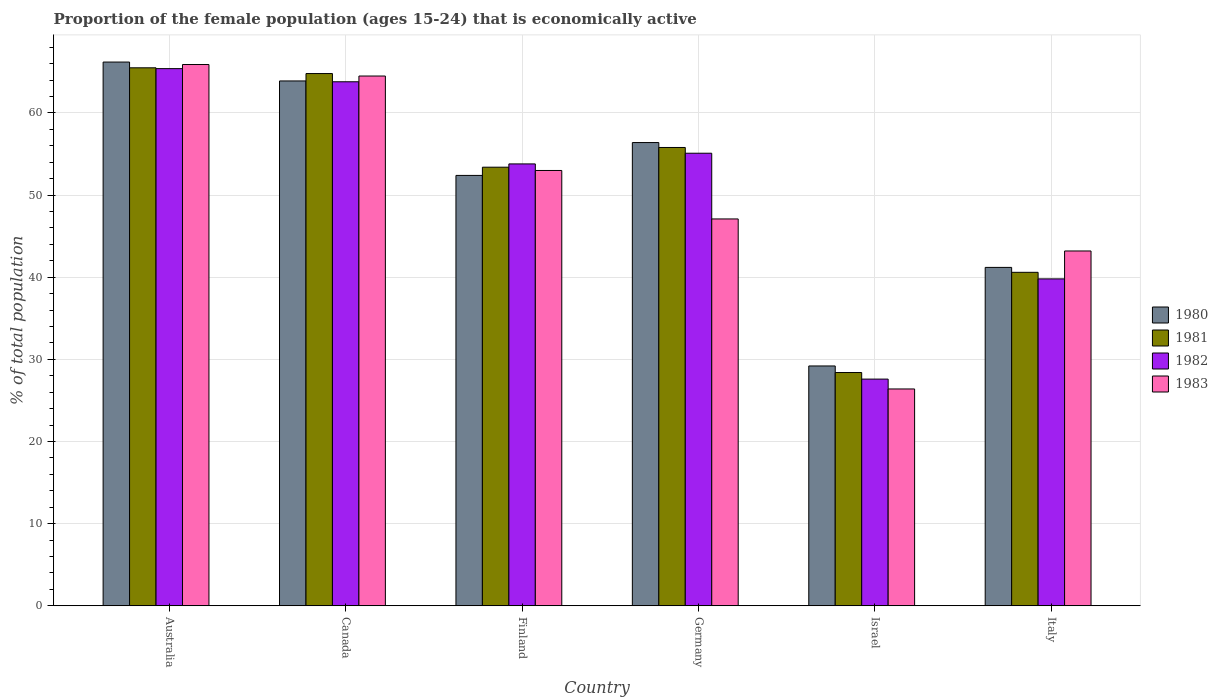How many groups of bars are there?
Keep it short and to the point. 6. Are the number of bars per tick equal to the number of legend labels?
Keep it short and to the point. Yes. How many bars are there on the 2nd tick from the left?
Provide a short and direct response. 4. In how many cases, is the number of bars for a given country not equal to the number of legend labels?
Your answer should be compact. 0. What is the proportion of the female population that is economically active in 1982 in Germany?
Make the answer very short. 55.1. Across all countries, what is the maximum proportion of the female population that is economically active in 1981?
Your response must be concise. 65.5. Across all countries, what is the minimum proportion of the female population that is economically active in 1981?
Make the answer very short. 28.4. In which country was the proportion of the female population that is economically active in 1983 maximum?
Your answer should be compact. Australia. In which country was the proportion of the female population that is economically active in 1980 minimum?
Give a very brief answer. Israel. What is the total proportion of the female population that is economically active in 1983 in the graph?
Give a very brief answer. 300.1. What is the difference between the proportion of the female population that is economically active in 1982 in Germany and that in Israel?
Offer a very short reply. 27.5. What is the difference between the proportion of the female population that is economically active in 1982 in Israel and the proportion of the female population that is economically active in 1980 in Canada?
Make the answer very short. -36.3. What is the average proportion of the female population that is economically active in 1983 per country?
Keep it short and to the point. 50.02. What is the difference between the proportion of the female population that is economically active of/in 1981 and proportion of the female population that is economically active of/in 1980 in Israel?
Provide a succinct answer. -0.8. What is the ratio of the proportion of the female population that is economically active in 1981 in Germany to that in Israel?
Provide a succinct answer. 1.96. Is the proportion of the female population that is economically active in 1981 in Finland less than that in Israel?
Your answer should be very brief. No. Is the difference between the proportion of the female population that is economically active in 1981 in Canada and Finland greater than the difference between the proportion of the female population that is economically active in 1980 in Canada and Finland?
Provide a succinct answer. No. What is the difference between the highest and the second highest proportion of the female population that is economically active in 1980?
Make the answer very short. -9.8. What is the difference between the highest and the lowest proportion of the female population that is economically active in 1983?
Ensure brevity in your answer.  39.5. In how many countries, is the proportion of the female population that is economically active in 1982 greater than the average proportion of the female population that is economically active in 1982 taken over all countries?
Your answer should be compact. 4. Is the sum of the proportion of the female population that is economically active in 1981 in Canada and Israel greater than the maximum proportion of the female population that is economically active in 1980 across all countries?
Make the answer very short. Yes. Is it the case that in every country, the sum of the proportion of the female population that is economically active in 1982 and proportion of the female population that is economically active in 1983 is greater than the sum of proportion of the female population that is economically active in 1981 and proportion of the female population that is economically active in 1980?
Provide a short and direct response. No. Are all the bars in the graph horizontal?
Your answer should be very brief. No. How many countries are there in the graph?
Offer a terse response. 6. What is the difference between two consecutive major ticks on the Y-axis?
Make the answer very short. 10. Are the values on the major ticks of Y-axis written in scientific E-notation?
Your response must be concise. No. Does the graph contain grids?
Make the answer very short. Yes. How many legend labels are there?
Offer a terse response. 4. How are the legend labels stacked?
Your response must be concise. Vertical. What is the title of the graph?
Give a very brief answer. Proportion of the female population (ages 15-24) that is economically active. What is the label or title of the Y-axis?
Keep it short and to the point. % of total population. What is the % of total population in 1980 in Australia?
Provide a succinct answer. 66.2. What is the % of total population of 1981 in Australia?
Your answer should be very brief. 65.5. What is the % of total population of 1982 in Australia?
Your answer should be compact. 65.4. What is the % of total population of 1983 in Australia?
Offer a very short reply. 65.9. What is the % of total population of 1980 in Canada?
Provide a short and direct response. 63.9. What is the % of total population in 1981 in Canada?
Provide a succinct answer. 64.8. What is the % of total population in 1982 in Canada?
Your response must be concise. 63.8. What is the % of total population of 1983 in Canada?
Your answer should be compact. 64.5. What is the % of total population in 1980 in Finland?
Provide a succinct answer. 52.4. What is the % of total population in 1981 in Finland?
Make the answer very short. 53.4. What is the % of total population of 1982 in Finland?
Ensure brevity in your answer.  53.8. What is the % of total population in 1983 in Finland?
Ensure brevity in your answer.  53. What is the % of total population of 1980 in Germany?
Your response must be concise. 56.4. What is the % of total population in 1981 in Germany?
Ensure brevity in your answer.  55.8. What is the % of total population in 1982 in Germany?
Offer a very short reply. 55.1. What is the % of total population of 1983 in Germany?
Provide a succinct answer. 47.1. What is the % of total population of 1980 in Israel?
Your response must be concise. 29.2. What is the % of total population of 1981 in Israel?
Keep it short and to the point. 28.4. What is the % of total population of 1982 in Israel?
Your answer should be compact. 27.6. What is the % of total population of 1983 in Israel?
Give a very brief answer. 26.4. What is the % of total population in 1980 in Italy?
Your answer should be compact. 41.2. What is the % of total population of 1981 in Italy?
Give a very brief answer. 40.6. What is the % of total population in 1982 in Italy?
Your response must be concise. 39.8. What is the % of total population of 1983 in Italy?
Your response must be concise. 43.2. Across all countries, what is the maximum % of total population of 1980?
Give a very brief answer. 66.2. Across all countries, what is the maximum % of total population of 1981?
Your answer should be compact. 65.5. Across all countries, what is the maximum % of total population of 1982?
Provide a short and direct response. 65.4. Across all countries, what is the maximum % of total population in 1983?
Your answer should be compact. 65.9. Across all countries, what is the minimum % of total population in 1980?
Offer a terse response. 29.2. Across all countries, what is the minimum % of total population in 1981?
Offer a very short reply. 28.4. Across all countries, what is the minimum % of total population in 1982?
Make the answer very short. 27.6. Across all countries, what is the minimum % of total population in 1983?
Your answer should be very brief. 26.4. What is the total % of total population of 1980 in the graph?
Provide a succinct answer. 309.3. What is the total % of total population of 1981 in the graph?
Provide a short and direct response. 308.5. What is the total % of total population in 1982 in the graph?
Provide a short and direct response. 305.5. What is the total % of total population of 1983 in the graph?
Offer a very short reply. 300.1. What is the difference between the % of total population in 1982 in Australia and that in Canada?
Make the answer very short. 1.6. What is the difference between the % of total population in 1983 in Australia and that in Canada?
Offer a very short reply. 1.4. What is the difference between the % of total population of 1980 in Australia and that in Finland?
Keep it short and to the point. 13.8. What is the difference between the % of total population of 1981 in Australia and that in Finland?
Your answer should be very brief. 12.1. What is the difference between the % of total population of 1982 in Australia and that in Finland?
Provide a succinct answer. 11.6. What is the difference between the % of total population in 1980 in Australia and that in Germany?
Give a very brief answer. 9.8. What is the difference between the % of total population in 1982 in Australia and that in Germany?
Give a very brief answer. 10.3. What is the difference between the % of total population of 1980 in Australia and that in Israel?
Provide a short and direct response. 37. What is the difference between the % of total population in 1981 in Australia and that in Israel?
Offer a very short reply. 37.1. What is the difference between the % of total population of 1982 in Australia and that in Israel?
Offer a very short reply. 37.8. What is the difference between the % of total population of 1983 in Australia and that in Israel?
Your answer should be compact. 39.5. What is the difference between the % of total population of 1981 in Australia and that in Italy?
Your answer should be very brief. 24.9. What is the difference between the % of total population in 1982 in Australia and that in Italy?
Provide a short and direct response. 25.6. What is the difference between the % of total population in 1983 in Australia and that in Italy?
Make the answer very short. 22.7. What is the difference between the % of total population in 1983 in Canada and that in Finland?
Keep it short and to the point. 11.5. What is the difference between the % of total population in 1980 in Canada and that in Israel?
Give a very brief answer. 34.7. What is the difference between the % of total population of 1981 in Canada and that in Israel?
Your answer should be compact. 36.4. What is the difference between the % of total population of 1982 in Canada and that in Israel?
Provide a short and direct response. 36.2. What is the difference between the % of total population of 1983 in Canada and that in Israel?
Provide a short and direct response. 38.1. What is the difference between the % of total population of 1980 in Canada and that in Italy?
Your answer should be very brief. 22.7. What is the difference between the % of total population in 1981 in Canada and that in Italy?
Offer a terse response. 24.2. What is the difference between the % of total population in 1983 in Canada and that in Italy?
Give a very brief answer. 21.3. What is the difference between the % of total population of 1980 in Finland and that in Germany?
Your response must be concise. -4. What is the difference between the % of total population in 1981 in Finland and that in Germany?
Ensure brevity in your answer.  -2.4. What is the difference between the % of total population of 1982 in Finland and that in Germany?
Give a very brief answer. -1.3. What is the difference between the % of total population of 1983 in Finland and that in Germany?
Give a very brief answer. 5.9. What is the difference between the % of total population of 1980 in Finland and that in Israel?
Your response must be concise. 23.2. What is the difference between the % of total population in 1981 in Finland and that in Israel?
Your response must be concise. 25. What is the difference between the % of total population in 1982 in Finland and that in Israel?
Offer a terse response. 26.2. What is the difference between the % of total population of 1983 in Finland and that in Israel?
Keep it short and to the point. 26.6. What is the difference between the % of total population of 1983 in Finland and that in Italy?
Your answer should be very brief. 9.8. What is the difference between the % of total population in 1980 in Germany and that in Israel?
Your response must be concise. 27.2. What is the difference between the % of total population of 1981 in Germany and that in Israel?
Your response must be concise. 27.4. What is the difference between the % of total population of 1982 in Germany and that in Israel?
Give a very brief answer. 27.5. What is the difference between the % of total population in 1983 in Germany and that in Israel?
Your response must be concise. 20.7. What is the difference between the % of total population of 1980 in Germany and that in Italy?
Offer a very short reply. 15.2. What is the difference between the % of total population in 1983 in Germany and that in Italy?
Make the answer very short. 3.9. What is the difference between the % of total population of 1982 in Israel and that in Italy?
Offer a terse response. -12.2. What is the difference between the % of total population of 1983 in Israel and that in Italy?
Give a very brief answer. -16.8. What is the difference between the % of total population of 1980 in Australia and the % of total population of 1981 in Canada?
Provide a succinct answer. 1.4. What is the difference between the % of total population in 1981 in Australia and the % of total population in 1983 in Canada?
Offer a very short reply. 1. What is the difference between the % of total population of 1981 in Australia and the % of total population of 1982 in Finland?
Make the answer very short. 11.7. What is the difference between the % of total population in 1980 in Australia and the % of total population in 1981 in Germany?
Your answer should be compact. 10.4. What is the difference between the % of total population of 1981 in Australia and the % of total population of 1983 in Germany?
Give a very brief answer. 18.4. What is the difference between the % of total population of 1980 in Australia and the % of total population of 1981 in Israel?
Keep it short and to the point. 37.8. What is the difference between the % of total population in 1980 in Australia and the % of total population in 1982 in Israel?
Your answer should be compact. 38.6. What is the difference between the % of total population in 1980 in Australia and the % of total population in 1983 in Israel?
Provide a succinct answer. 39.8. What is the difference between the % of total population in 1981 in Australia and the % of total population in 1982 in Israel?
Your response must be concise. 37.9. What is the difference between the % of total population in 1981 in Australia and the % of total population in 1983 in Israel?
Make the answer very short. 39.1. What is the difference between the % of total population of 1980 in Australia and the % of total population of 1981 in Italy?
Your answer should be compact. 25.6. What is the difference between the % of total population in 1980 in Australia and the % of total population in 1982 in Italy?
Provide a succinct answer. 26.4. What is the difference between the % of total population of 1981 in Australia and the % of total population of 1982 in Italy?
Your answer should be very brief. 25.7. What is the difference between the % of total population of 1981 in Australia and the % of total population of 1983 in Italy?
Offer a very short reply. 22.3. What is the difference between the % of total population of 1980 in Canada and the % of total population of 1981 in Finland?
Your response must be concise. 10.5. What is the difference between the % of total population of 1980 in Canada and the % of total population of 1983 in Finland?
Keep it short and to the point. 10.9. What is the difference between the % of total population in 1981 in Canada and the % of total population in 1983 in Finland?
Provide a succinct answer. 11.8. What is the difference between the % of total population in 1982 in Canada and the % of total population in 1983 in Finland?
Your response must be concise. 10.8. What is the difference between the % of total population in 1980 in Canada and the % of total population in 1981 in Germany?
Your answer should be very brief. 8.1. What is the difference between the % of total population in 1980 in Canada and the % of total population in 1983 in Germany?
Offer a very short reply. 16.8. What is the difference between the % of total population of 1981 in Canada and the % of total population of 1982 in Germany?
Provide a short and direct response. 9.7. What is the difference between the % of total population of 1980 in Canada and the % of total population of 1981 in Israel?
Keep it short and to the point. 35.5. What is the difference between the % of total population of 1980 in Canada and the % of total population of 1982 in Israel?
Provide a short and direct response. 36.3. What is the difference between the % of total population in 1980 in Canada and the % of total population in 1983 in Israel?
Ensure brevity in your answer.  37.5. What is the difference between the % of total population in 1981 in Canada and the % of total population in 1982 in Israel?
Ensure brevity in your answer.  37.2. What is the difference between the % of total population in 1981 in Canada and the % of total population in 1983 in Israel?
Your answer should be compact. 38.4. What is the difference between the % of total population of 1982 in Canada and the % of total population of 1983 in Israel?
Ensure brevity in your answer.  37.4. What is the difference between the % of total population in 1980 in Canada and the % of total population in 1981 in Italy?
Provide a succinct answer. 23.3. What is the difference between the % of total population in 1980 in Canada and the % of total population in 1982 in Italy?
Make the answer very short. 24.1. What is the difference between the % of total population in 1980 in Canada and the % of total population in 1983 in Italy?
Offer a terse response. 20.7. What is the difference between the % of total population of 1981 in Canada and the % of total population of 1983 in Italy?
Provide a succinct answer. 21.6. What is the difference between the % of total population in 1982 in Canada and the % of total population in 1983 in Italy?
Provide a succinct answer. 20.6. What is the difference between the % of total population in 1980 in Finland and the % of total population in 1981 in Germany?
Give a very brief answer. -3.4. What is the difference between the % of total population of 1980 in Finland and the % of total population of 1983 in Germany?
Your answer should be compact. 5.3. What is the difference between the % of total population of 1981 in Finland and the % of total population of 1982 in Germany?
Your answer should be compact. -1.7. What is the difference between the % of total population in 1981 in Finland and the % of total population in 1983 in Germany?
Your answer should be compact. 6.3. What is the difference between the % of total population of 1982 in Finland and the % of total population of 1983 in Germany?
Your response must be concise. 6.7. What is the difference between the % of total population in 1980 in Finland and the % of total population in 1981 in Israel?
Your answer should be compact. 24. What is the difference between the % of total population of 1980 in Finland and the % of total population of 1982 in Israel?
Your answer should be compact. 24.8. What is the difference between the % of total population of 1981 in Finland and the % of total population of 1982 in Israel?
Your response must be concise. 25.8. What is the difference between the % of total population of 1981 in Finland and the % of total population of 1983 in Israel?
Provide a succinct answer. 27. What is the difference between the % of total population in 1982 in Finland and the % of total population in 1983 in Israel?
Offer a very short reply. 27.4. What is the difference between the % of total population in 1980 in Finland and the % of total population in 1981 in Italy?
Your answer should be very brief. 11.8. What is the difference between the % of total population in 1980 in Finland and the % of total population in 1982 in Italy?
Keep it short and to the point. 12.6. What is the difference between the % of total population of 1980 in Finland and the % of total population of 1983 in Italy?
Your answer should be compact. 9.2. What is the difference between the % of total population in 1981 in Finland and the % of total population in 1983 in Italy?
Offer a very short reply. 10.2. What is the difference between the % of total population of 1980 in Germany and the % of total population of 1981 in Israel?
Your answer should be very brief. 28. What is the difference between the % of total population of 1980 in Germany and the % of total population of 1982 in Israel?
Give a very brief answer. 28.8. What is the difference between the % of total population of 1981 in Germany and the % of total population of 1982 in Israel?
Your response must be concise. 28.2. What is the difference between the % of total population in 1981 in Germany and the % of total population in 1983 in Israel?
Make the answer very short. 29.4. What is the difference between the % of total population of 1982 in Germany and the % of total population of 1983 in Israel?
Offer a terse response. 28.7. What is the difference between the % of total population of 1980 in Germany and the % of total population of 1982 in Italy?
Provide a succinct answer. 16.6. What is the difference between the % of total population in 1981 in Germany and the % of total population in 1982 in Italy?
Your answer should be very brief. 16. What is the difference between the % of total population of 1980 in Israel and the % of total population of 1981 in Italy?
Offer a terse response. -11.4. What is the difference between the % of total population of 1980 in Israel and the % of total population of 1982 in Italy?
Provide a short and direct response. -10.6. What is the difference between the % of total population of 1980 in Israel and the % of total population of 1983 in Italy?
Give a very brief answer. -14. What is the difference between the % of total population of 1981 in Israel and the % of total population of 1983 in Italy?
Give a very brief answer. -14.8. What is the difference between the % of total population of 1982 in Israel and the % of total population of 1983 in Italy?
Ensure brevity in your answer.  -15.6. What is the average % of total population in 1980 per country?
Offer a terse response. 51.55. What is the average % of total population in 1981 per country?
Keep it short and to the point. 51.42. What is the average % of total population of 1982 per country?
Offer a very short reply. 50.92. What is the average % of total population of 1983 per country?
Your response must be concise. 50.02. What is the difference between the % of total population of 1980 and % of total population of 1981 in Australia?
Provide a short and direct response. 0.7. What is the difference between the % of total population of 1980 and % of total population of 1982 in Australia?
Your response must be concise. 0.8. What is the difference between the % of total population of 1980 and % of total population of 1983 in Australia?
Your answer should be very brief. 0.3. What is the difference between the % of total population of 1981 and % of total population of 1982 in Australia?
Give a very brief answer. 0.1. What is the difference between the % of total population in 1981 and % of total population in 1983 in Australia?
Keep it short and to the point. -0.4. What is the difference between the % of total population in 1980 and % of total population in 1981 in Canada?
Make the answer very short. -0.9. What is the difference between the % of total population of 1980 and % of total population of 1982 in Canada?
Ensure brevity in your answer.  0.1. What is the difference between the % of total population of 1981 and % of total population of 1983 in Canada?
Your answer should be very brief. 0.3. What is the difference between the % of total population in 1980 and % of total population in 1981 in Finland?
Your answer should be compact. -1. What is the difference between the % of total population in 1980 and % of total population in 1982 in Finland?
Offer a very short reply. -1.4. What is the difference between the % of total population of 1980 and % of total population of 1983 in Finland?
Give a very brief answer. -0.6. What is the difference between the % of total population of 1981 and % of total population of 1983 in Finland?
Provide a succinct answer. 0.4. What is the difference between the % of total population in 1980 and % of total population in 1982 in Germany?
Keep it short and to the point. 1.3. What is the difference between the % of total population of 1981 and % of total population of 1983 in Germany?
Offer a very short reply. 8.7. What is the difference between the % of total population of 1982 and % of total population of 1983 in Germany?
Make the answer very short. 8. What is the difference between the % of total population in 1980 and % of total population in 1983 in Israel?
Offer a terse response. 2.8. What is the difference between the % of total population of 1981 and % of total population of 1982 in Israel?
Make the answer very short. 0.8. What is the difference between the % of total population of 1980 and % of total population of 1981 in Italy?
Offer a terse response. 0.6. What is the difference between the % of total population in 1980 and % of total population in 1982 in Italy?
Offer a very short reply. 1.4. What is the difference between the % of total population of 1981 and % of total population of 1982 in Italy?
Make the answer very short. 0.8. What is the difference between the % of total population of 1981 and % of total population of 1983 in Italy?
Provide a succinct answer. -2.6. What is the ratio of the % of total population in 1980 in Australia to that in Canada?
Your answer should be compact. 1.04. What is the ratio of the % of total population of 1981 in Australia to that in Canada?
Your response must be concise. 1.01. What is the ratio of the % of total population in 1982 in Australia to that in Canada?
Offer a terse response. 1.03. What is the ratio of the % of total population of 1983 in Australia to that in Canada?
Give a very brief answer. 1.02. What is the ratio of the % of total population of 1980 in Australia to that in Finland?
Offer a terse response. 1.26. What is the ratio of the % of total population in 1981 in Australia to that in Finland?
Your response must be concise. 1.23. What is the ratio of the % of total population in 1982 in Australia to that in Finland?
Keep it short and to the point. 1.22. What is the ratio of the % of total population in 1983 in Australia to that in Finland?
Give a very brief answer. 1.24. What is the ratio of the % of total population in 1980 in Australia to that in Germany?
Keep it short and to the point. 1.17. What is the ratio of the % of total population in 1981 in Australia to that in Germany?
Your answer should be compact. 1.17. What is the ratio of the % of total population of 1982 in Australia to that in Germany?
Offer a terse response. 1.19. What is the ratio of the % of total population of 1983 in Australia to that in Germany?
Offer a very short reply. 1.4. What is the ratio of the % of total population of 1980 in Australia to that in Israel?
Provide a short and direct response. 2.27. What is the ratio of the % of total population in 1981 in Australia to that in Israel?
Give a very brief answer. 2.31. What is the ratio of the % of total population of 1982 in Australia to that in Israel?
Your answer should be compact. 2.37. What is the ratio of the % of total population of 1983 in Australia to that in Israel?
Your answer should be very brief. 2.5. What is the ratio of the % of total population of 1980 in Australia to that in Italy?
Offer a very short reply. 1.61. What is the ratio of the % of total population of 1981 in Australia to that in Italy?
Keep it short and to the point. 1.61. What is the ratio of the % of total population of 1982 in Australia to that in Italy?
Give a very brief answer. 1.64. What is the ratio of the % of total population in 1983 in Australia to that in Italy?
Your answer should be compact. 1.53. What is the ratio of the % of total population in 1980 in Canada to that in Finland?
Keep it short and to the point. 1.22. What is the ratio of the % of total population of 1981 in Canada to that in Finland?
Provide a succinct answer. 1.21. What is the ratio of the % of total population in 1982 in Canada to that in Finland?
Make the answer very short. 1.19. What is the ratio of the % of total population of 1983 in Canada to that in Finland?
Keep it short and to the point. 1.22. What is the ratio of the % of total population in 1980 in Canada to that in Germany?
Your answer should be compact. 1.13. What is the ratio of the % of total population in 1981 in Canada to that in Germany?
Offer a very short reply. 1.16. What is the ratio of the % of total population of 1982 in Canada to that in Germany?
Provide a short and direct response. 1.16. What is the ratio of the % of total population of 1983 in Canada to that in Germany?
Give a very brief answer. 1.37. What is the ratio of the % of total population of 1980 in Canada to that in Israel?
Provide a short and direct response. 2.19. What is the ratio of the % of total population of 1981 in Canada to that in Israel?
Provide a short and direct response. 2.28. What is the ratio of the % of total population of 1982 in Canada to that in Israel?
Keep it short and to the point. 2.31. What is the ratio of the % of total population in 1983 in Canada to that in Israel?
Offer a very short reply. 2.44. What is the ratio of the % of total population of 1980 in Canada to that in Italy?
Give a very brief answer. 1.55. What is the ratio of the % of total population in 1981 in Canada to that in Italy?
Ensure brevity in your answer.  1.6. What is the ratio of the % of total population in 1982 in Canada to that in Italy?
Offer a terse response. 1.6. What is the ratio of the % of total population of 1983 in Canada to that in Italy?
Offer a very short reply. 1.49. What is the ratio of the % of total population of 1980 in Finland to that in Germany?
Your response must be concise. 0.93. What is the ratio of the % of total population in 1981 in Finland to that in Germany?
Your response must be concise. 0.96. What is the ratio of the % of total population of 1982 in Finland to that in Germany?
Offer a very short reply. 0.98. What is the ratio of the % of total population of 1983 in Finland to that in Germany?
Ensure brevity in your answer.  1.13. What is the ratio of the % of total population in 1980 in Finland to that in Israel?
Make the answer very short. 1.79. What is the ratio of the % of total population in 1981 in Finland to that in Israel?
Give a very brief answer. 1.88. What is the ratio of the % of total population of 1982 in Finland to that in Israel?
Offer a very short reply. 1.95. What is the ratio of the % of total population of 1983 in Finland to that in Israel?
Ensure brevity in your answer.  2.01. What is the ratio of the % of total population in 1980 in Finland to that in Italy?
Your answer should be compact. 1.27. What is the ratio of the % of total population of 1981 in Finland to that in Italy?
Your response must be concise. 1.32. What is the ratio of the % of total population of 1982 in Finland to that in Italy?
Your answer should be very brief. 1.35. What is the ratio of the % of total population of 1983 in Finland to that in Italy?
Offer a very short reply. 1.23. What is the ratio of the % of total population in 1980 in Germany to that in Israel?
Provide a short and direct response. 1.93. What is the ratio of the % of total population of 1981 in Germany to that in Israel?
Your answer should be very brief. 1.96. What is the ratio of the % of total population in 1982 in Germany to that in Israel?
Provide a succinct answer. 2. What is the ratio of the % of total population of 1983 in Germany to that in Israel?
Offer a terse response. 1.78. What is the ratio of the % of total population in 1980 in Germany to that in Italy?
Ensure brevity in your answer.  1.37. What is the ratio of the % of total population in 1981 in Germany to that in Italy?
Offer a terse response. 1.37. What is the ratio of the % of total population of 1982 in Germany to that in Italy?
Your answer should be very brief. 1.38. What is the ratio of the % of total population in 1983 in Germany to that in Italy?
Your response must be concise. 1.09. What is the ratio of the % of total population in 1980 in Israel to that in Italy?
Make the answer very short. 0.71. What is the ratio of the % of total population of 1981 in Israel to that in Italy?
Provide a succinct answer. 0.7. What is the ratio of the % of total population in 1982 in Israel to that in Italy?
Provide a short and direct response. 0.69. What is the ratio of the % of total population in 1983 in Israel to that in Italy?
Provide a short and direct response. 0.61. What is the difference between the highest and the second highest % of total population in 1980?
Give a very brief answer. 2.3. What is the difference between the highest and the second highest % of total population of 1981?
Provide a short and direct response. 0.7. What is the difference between the highest and the lowest % of total population of 1980?
Your answer should be very brief. 37. What is the difference between the highest and the lowest % of total population of 1981?
Provide a short and direct response. 37.1. What is the difference between the highest and the lowest % of total population of 1982?
Offer a terse response. 37.8. What is the difference between the highest and the lowest % of total population of 1983?
Ensure brevity in your answer.  39.5. 